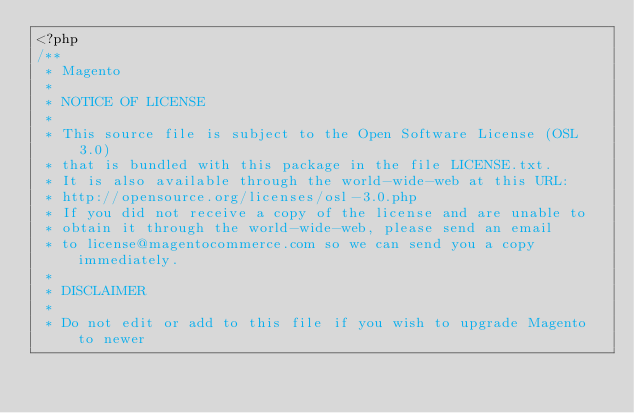Convert code to text. <code><loc_0><loc_0><loc_500><loc_500><_PHP_><?php
/**
 * Magento
 *
 * NOTICE OF LICENSE
 *
 * This source file is subject to the Open Software License (OSL 3.0)
 * that is bundled with this package in the file LICENSE.txt.
 * It is also available through the world-wide-web at this URL:
 * http://opensource.org/licenses/osl-3.0.php
 * If you did not receive a copy of the license and are unable to
 * obtain it through the world-wide-web, please send an email
 * to license@magentocommerce.com so we can send you a copy immediately.
 *
 * DISCLAIMER
 *
 * Do not edit or add to this file if you wish to upgrade Magento to newer</code> 